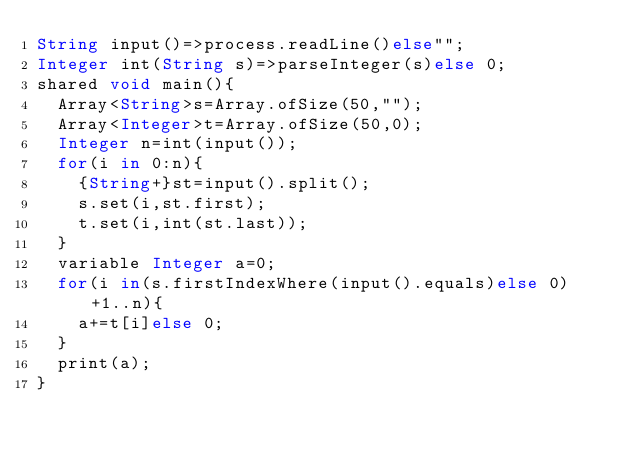Convert code to text. <code><loc_0><loc_0><loc_500><loc_500><_Ceylon_>String input()=>process.readLine()else""; 
Integer int(String s)=>parseInteger(s)else 0;
shared void main(){
  Array<String>s=Array.ofSize(50,"");
  Array<Integer>t=Array.ofSize(50,0);
  Integer n=int(input());
  for(i in 0:n){
    {String+}st=input().split();
    s.set(i,st.first);
    t.set(i,int(st.last));
  }
  variable Integer a=0;
  for(i in(s.firstIndexWhere(input().equals)else 0)+1..n){
    a+=t[i]else 0;
  }
  print(a);
}
</code> 